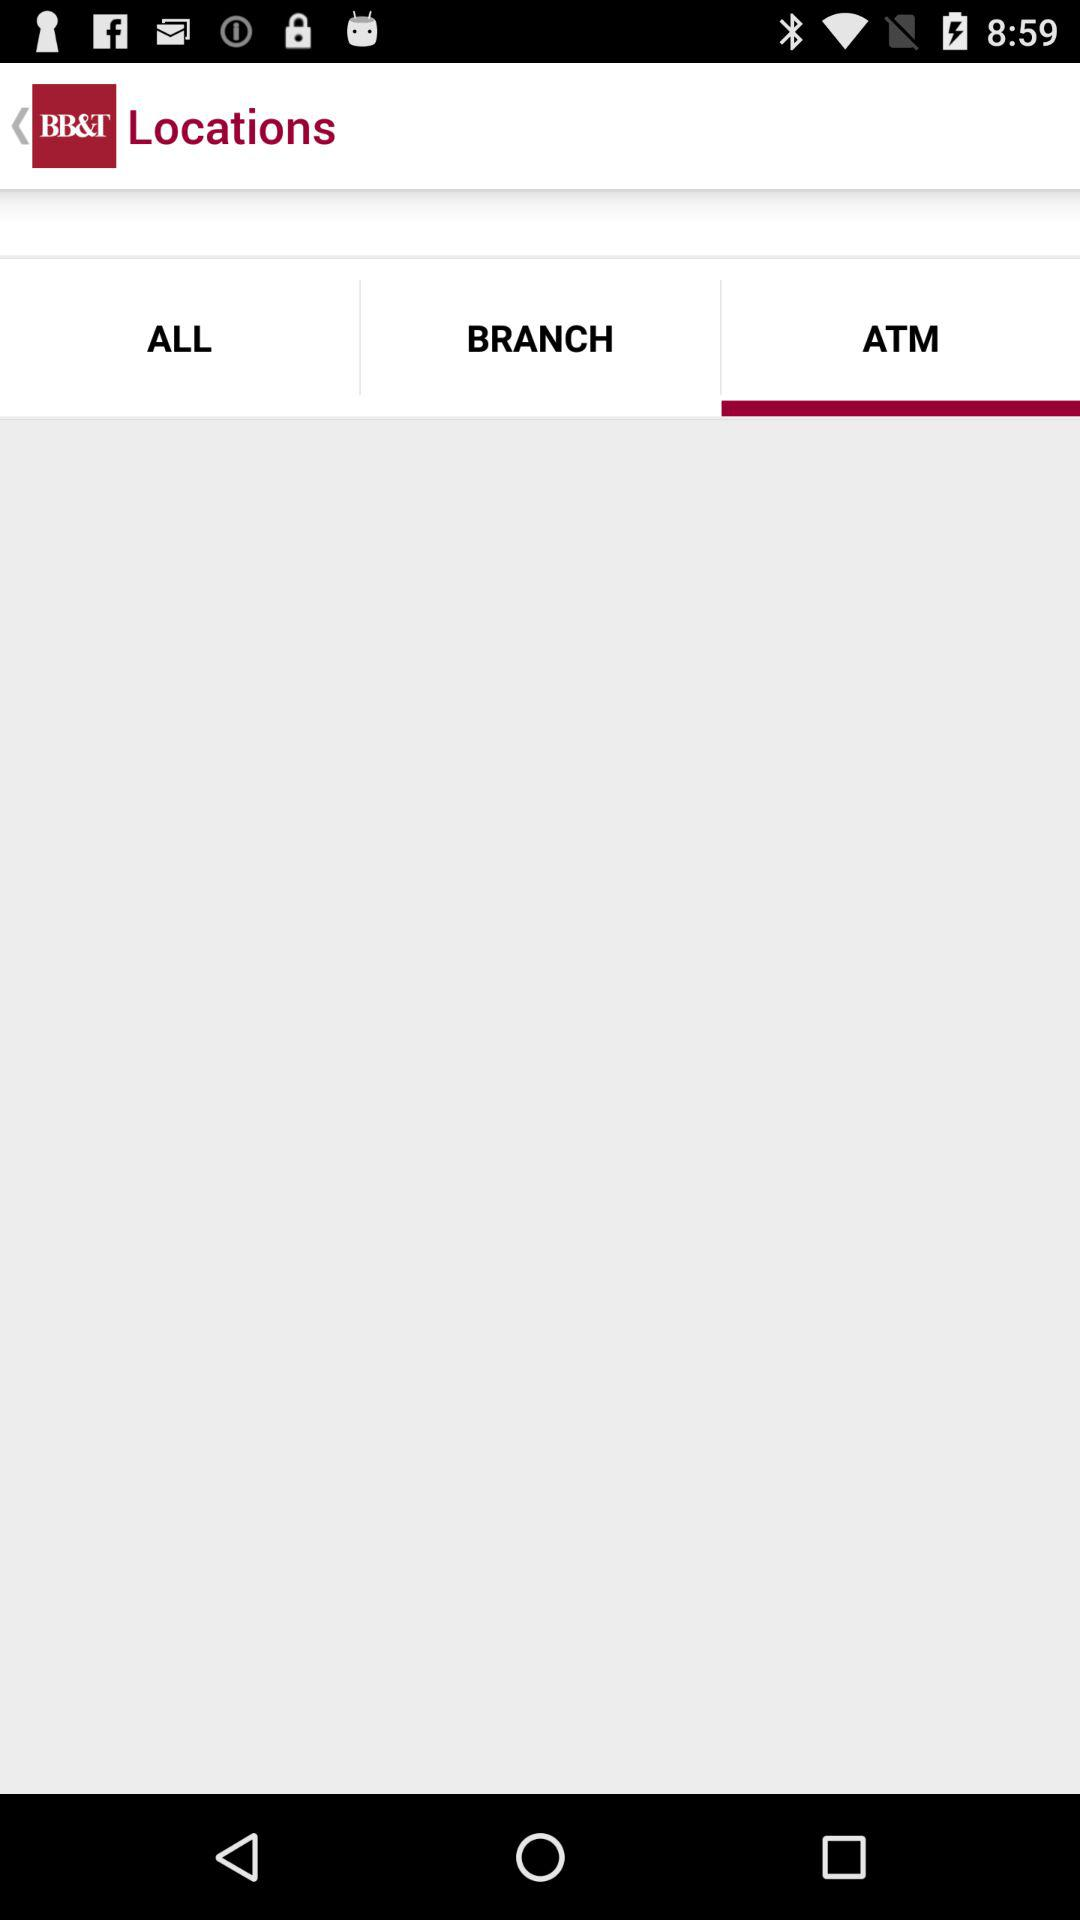What is the application name? The application name is "BB&T". 